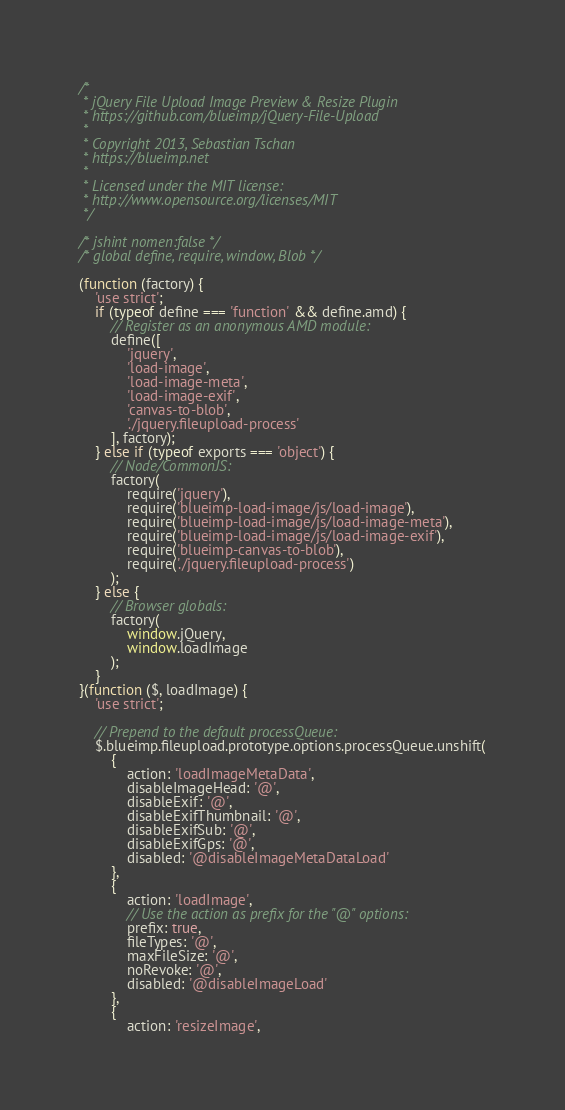Convert code to text. <code><loc_0><loc_0><loc_500><loc_500><_JavaScript_>/*
 * jQuery File Upload Image Preview & Resize Plugin
 * https://github.com/blueimp/jQuery-File-Upload
 *
 * Copyright 2013, Sebastian Tschan
 * https://blueimp.net
 *
 * Licensed under the MIT license:
 * http://www.opensource.org/licenses/MIT
 */

/* jshint nomen:false */
/* global define, require, window, Blob */

(function (factory) {
    'use strict';
    if (typeof define === 'function' && define.amd) {
        // Register as an anonymous AMD module:
        define([
            'jquery',
            'load-image',
            'load-image-meta',
            'load-image-exif',
            'canvas-to-blob',
            './jquery.fileupload-process'
        ], factory);
    } else if (typeof exports === 'object') {
        // Node/CommonJS:
        factory(
            require('jquery'),
            require('blueimp-load-image/js/load-image'),
            require('blueimp-load-image/js/load-image-meta'),
            require('blueimp-load-image/js/load-image-exif'),
            require('blueimp-canvas-to-blob'),
            require('./jquery.fileupload-process')
        );
    } else {
        // Browser globals:
        factory(
            window.jQuery,
            window.loadImage
        );
    }
}(function ($, loadImage) {
    'use strict';

    // Prepend to the default processQueue:
    $.blueimp.fileupload.prototype.options.processQueue.unshift(
        {
            action: 'loadImageMetaData',
            disableImageHead: '@',
            disableExif: '@',
            disableExifThumbnail: '@',
            disableExifSub: '@',
            disableExifGps: '@',
            disabled: '@disableImageMetaDataLoad'
        },
        {
            action: 'loadImage',
            // Use the action as prefix for the "@" options:
            prefix: true,
            fileTypes: '@',
            maxFileSize: '@',
            noRevoke: '@',
            disabled: '@disableImageLoad'
        },
        {
            action: 'resizeImage',</code> 